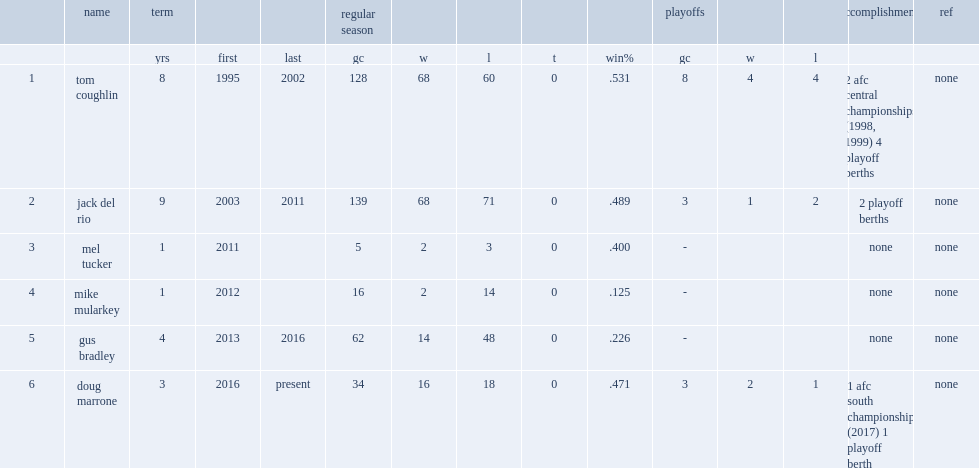Write the full table. {'header': ['', 'name', 'term', '', '', 'regular season', '', '', '', '', 'playoffs', '', '', 'accomplishments', 'ref'], 'rows': [['', '', 'yrs', 'first', 'last', 'gc', 'w', 'l', 't', 'win%', 'gc', 'w', 'l', '', ''], ['1', 'tom coughlin', '8', '1995', '2002', '128', '68', '60', '0', '.531', '8', '4', '4', '2 afc central championships (1998, 1999) 4 playoff berths', 'none'], ['2', 'jack del rio', '9', '2003', '2011', '139', '68', '71', '0', '.489', '3', '1', '2', '2 playoff berths', 'none'], ['3', 'mel tucker', '1', '2011', '', '5', '2', '3', '0', '.400', '-', '', '', 'none', 'none'], ['4', 'mike mularkey', '1', '2012', '', '16', '2', '14', '0', '.125', '-', '', '', 'none', 'none'], ['5', 'gus bradley', '4', '2013', '2016', '62', '14', '48', '0', '.226', '-', '', '', 'none', 'none'], ['6', 'doug marrone', '3', '2016', 'present', '34', '16', '18', '0', '.471', '3', '2', '1', '1 afc south championship (2017) 1 playoff berth', 'none']]} Who was the coach of the 2016 jacksonville jaguars season? Gus bradley. 